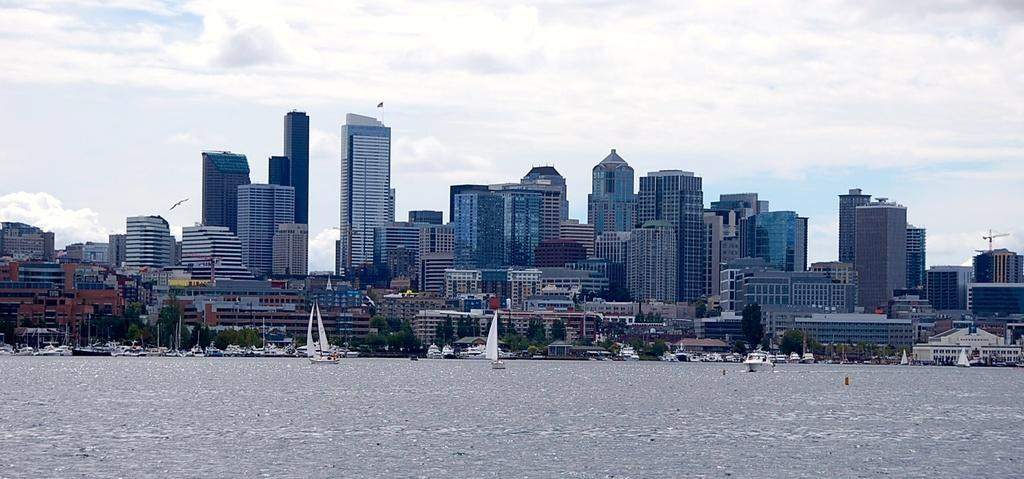What type of structures can be seen in the image? There are buildings in the image. What is located in the water in the image? There are boats in the water in the image. What type of vegetation is present in the image? There are trees in the image. What can be seen in the sky in the image? There are clouds visible in the sky in the image. What type of notebook is being used by the goose in the image? There is no goose or notebook present in the image. 